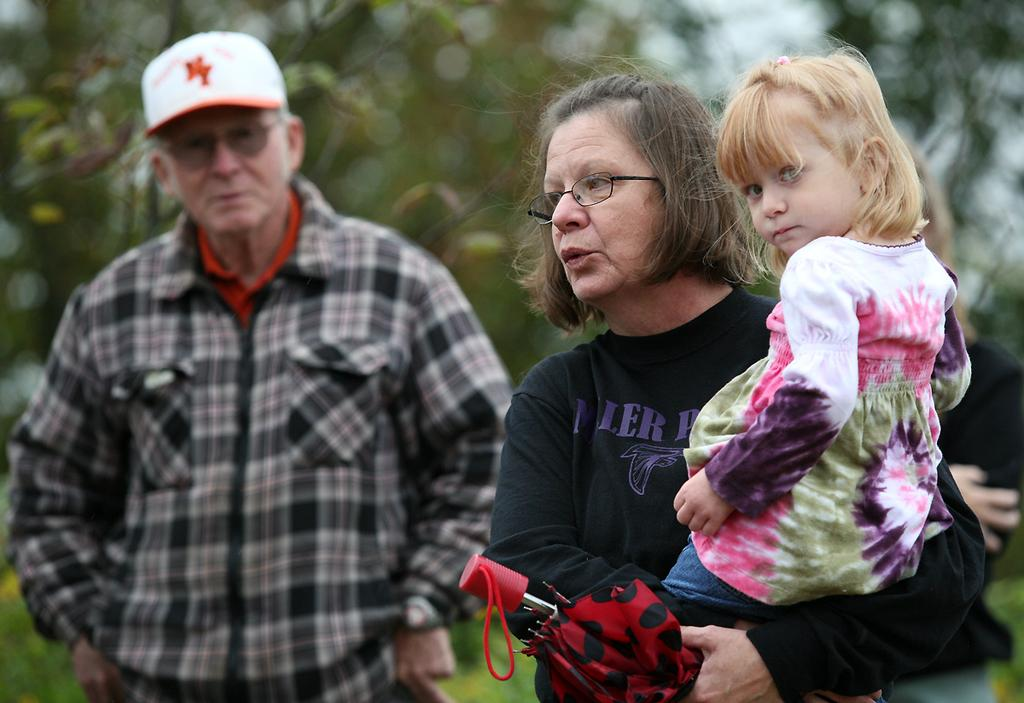What is the woman in the image doing? The woman is standing in the image and holding a kid. What object is the woman holding in addition to the kid? The woman is holding an umbrella. Who else is present in the image? There is a man standing in the image. What can be seen in the background of the image? Trees are visible in the background. What type of ground is present at the bottom of the image? Grass is present at the bottom of the image. What type of clover can be seen growing in the image? There is no clover visible in the image. What is the condition of the man's health in the image? The image does not provide any information about the man's health, so it cannot be determined. 